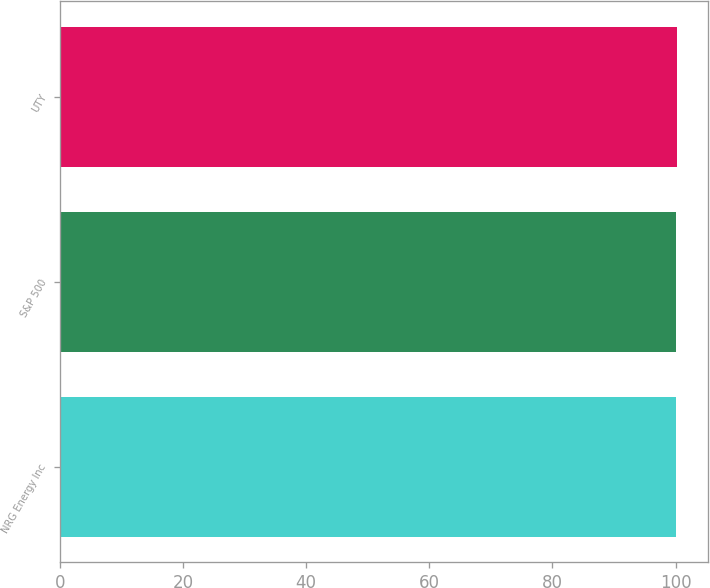Convert chart. <chart><loc_0><loc_0><loc_500><loc_500><bar_chart><fcel>NRG Energy Inc<fcel>S&P 500<fcel>UTY<nl><fcel>100<fcel>100.1<fcel>100.2<nl></chart> 